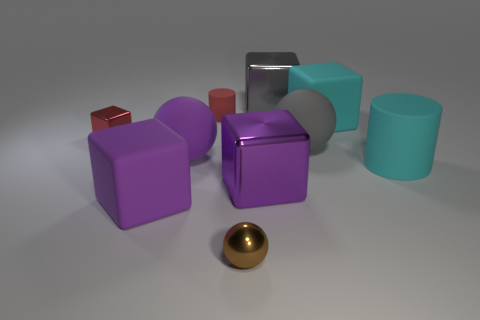Do any of these objects cast noticeable shadows, and what does that tell us about the lighting? Each object casts a soft shadow, indicating that the lighting in the scene is diffuse, probably from a source that's not directly above them, as there are shadows extending to different sides, suggesting an overhead but slightly angled light source. 